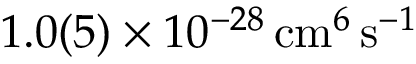Convert formula to latex. <formula><loc_0><loc_0><loc_500><loc_500>1 . 0 ( 5 ) \times 1 0 ^ { - 2 8 } \, c m ^ { 6 } \, s ^ { - 1 }</formula> 